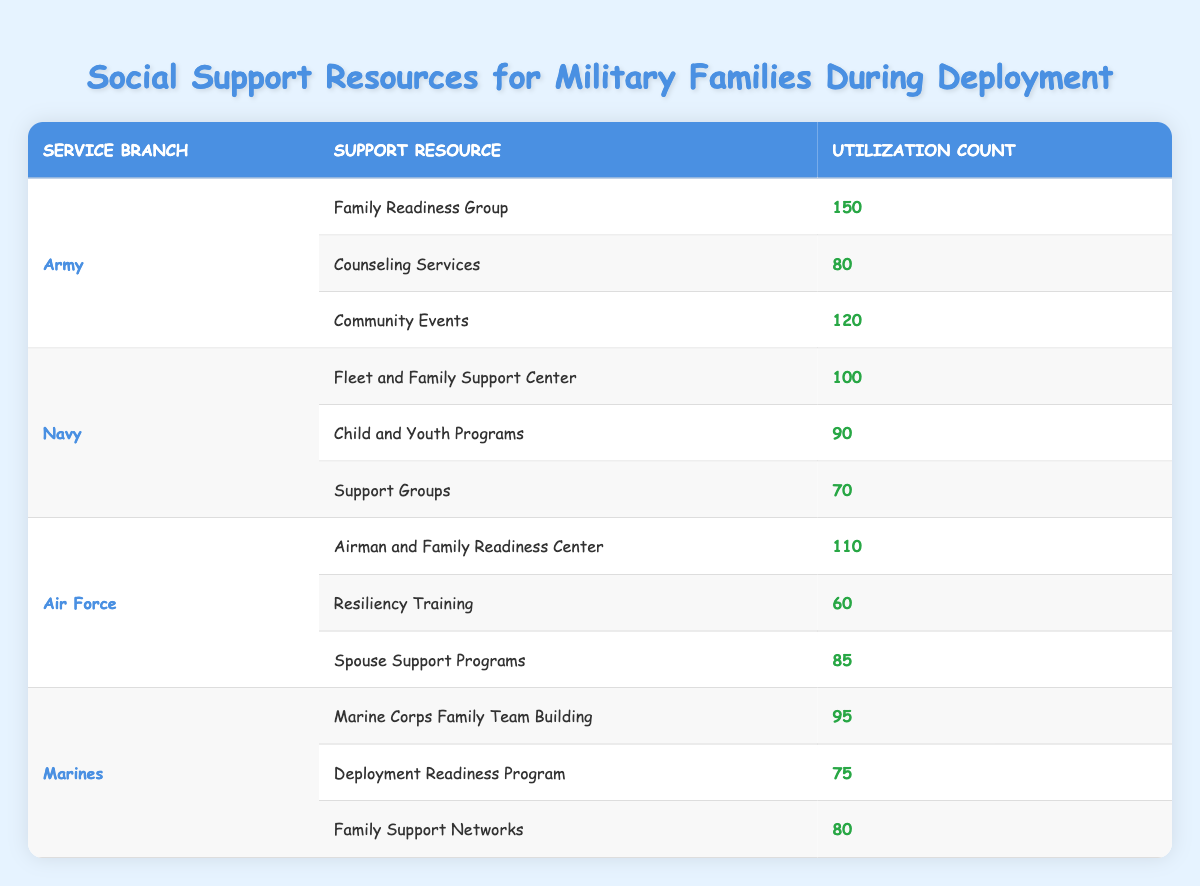What is the utilization count for the "Family Readiness Group" in the Army? The table shows that the Army has a utilization count of 150 for the "Family Readiness Group."
Answer: 150 Which support resource had the highest utilization count in the Navy? By looking at the Navy section, the support resource with the highest utilization count is the "Fleet and Family Support Center" with a count of 100.
Answer: 100 What is the total utilization count for Marine support resources? The total count for Marines is calculated by adding "Marine Corps Family Team Building" (95), "Deployment Readiness Program" (75), and "Family Support Networks" (80), which sums to 250 (95 + 75 + 80 = 250).
Answer: 250 Did the Air Force utilize "Resiliency Training" more than "Spouse Support Programs"? The Air Force utilized "Resiliency Training" with a count of 60 and "Spouse Support Programs" with a count of 85. Since 60 is less than 85, the answer is no.
Answer: No What is the average utilization count of support resources for the Army? There are three support resources for the Army: "Family Readiness Group" (150), "Counseling Services" (80), and "Community Events" (120). Their total is 350 (150 + 80 + 120 = 350), and dividing by 3 gives an average utilization of approximately 116.67 (350 / 3 = 116.67).
Answer: 116.67 Which service branch utilized "Counseling Services"? The table shows that "Counseling Services" is utilized by the Army, specifically with a count of 80.
Answer: Army How many more resources did the Marines utilize compared to the Air Force? The Marines utilized three resources: "Marine Corps Family Team Building" (95), "Deployment Readiness Program" (75), and "Family Support Networks" (80), totaling 250. The Air Force also utilized three resources: "Airman and Family Readiness Center" (110), "Resiliency Training" (60), and "Spouse Support Programs" (85), totaling 255 (110 + 60 + 85 = 255). Therefore, the Marines utilized 5 fewer resources than the Air Force (250 - 255 = -5).
Answer: 5 What resource is least utilized in the Navy? Among the Navy's support resources, "Support Groups" has the lowest utilization count of 70, making it the least utilized.
Answer: 70 What percentage of the overall utilization in the Army is due to "Community Events"? The Army has a total utilization count of 350, from which "Community Events" (120) constitutes approximately 34.29% (120 / 350 * 100).
Answer: 34.29% 